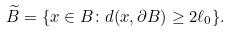<formula> <loc_0><loc_0><loc_500><loc_500>\widetilde { B } = \{ x \in B \colon d ( x , \partial B ) \geq 2 \ell _ { 0 } \} .</formula> 